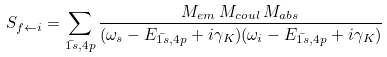<formula> <loc_0><loc_0><loc_500><loc_500>S _ { f \leftarrow i } = \sum _ { \bar { 1 s } , 4 p } \frac { M _ { e m } \, M _ { c o u l } \, M _ { a b s } } { ( \omega _ { s } - E _ { \bar { 1 s } , 4 p } + i \gamma _ { K } ) ( \omega _ { i } - E _ { \bar { 1 s } , 4 p } + i \gamma _ { K } ) }</formula> 